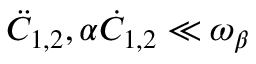<formula> <loc_0><loc_0><loc_500><loc_500>\ddot { C } _ { 1 , 2 } , \alpha \dot { C } _ { 1 , 2 } \ll \omega _ { \beta }</formula> 